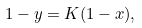<formula> <loc_0><loc_0><loc_500><loc_500>1 - y = K ( 1 - x ) ,</formula> 